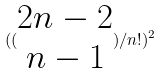Convert formula to latex. <formula><loc_0><loc_0><loc_500><loc_500>( ( \begin{matrix} 2 n - 2 \\ n - 1 \end{matrix} ) / n ! ) ^ { 2 }</formula> 